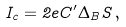Convert formula to latex. <formula><loc_0><loc_0><loc_500><loc_500>I _ { c } = 2 e C ^ { \prime } \Delta _ { B } S \, ,</formula> 